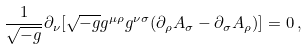Convert formula to latex. <formula><loc_0><loc_0><loc_500><loc_500>\frac { 1 } { \sqrt { - g } } \partial _ { \nu } [ \sqrt { - g } g ^ { \mu \rho } g ^ { \nu \sigma } ( \partial _ { \rho } A _ { \sigma } - \partial _ { \sigma } A _ { \rho } ) ] = 0 \, ,</formula> 